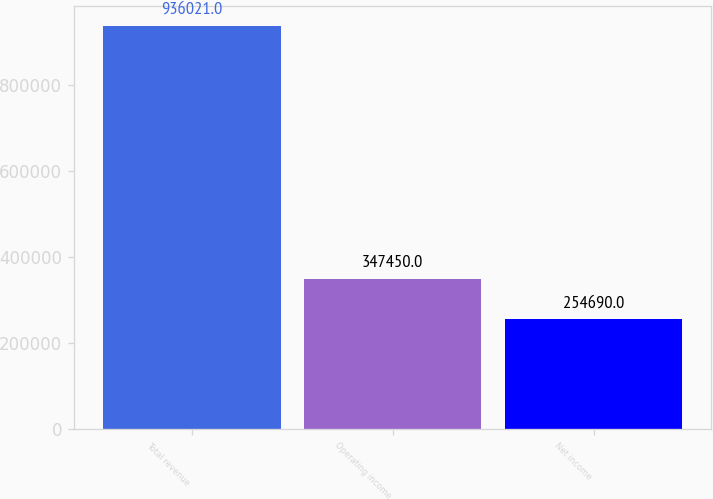<chart> <loc_0><loc_0><loc_500><loc_500><bar_chart><fcel>Total revenue<fcel>Operating income<fcel>Net income<nl><fcel>936021<fcel>347450<fcel>254690<nl></chart> 